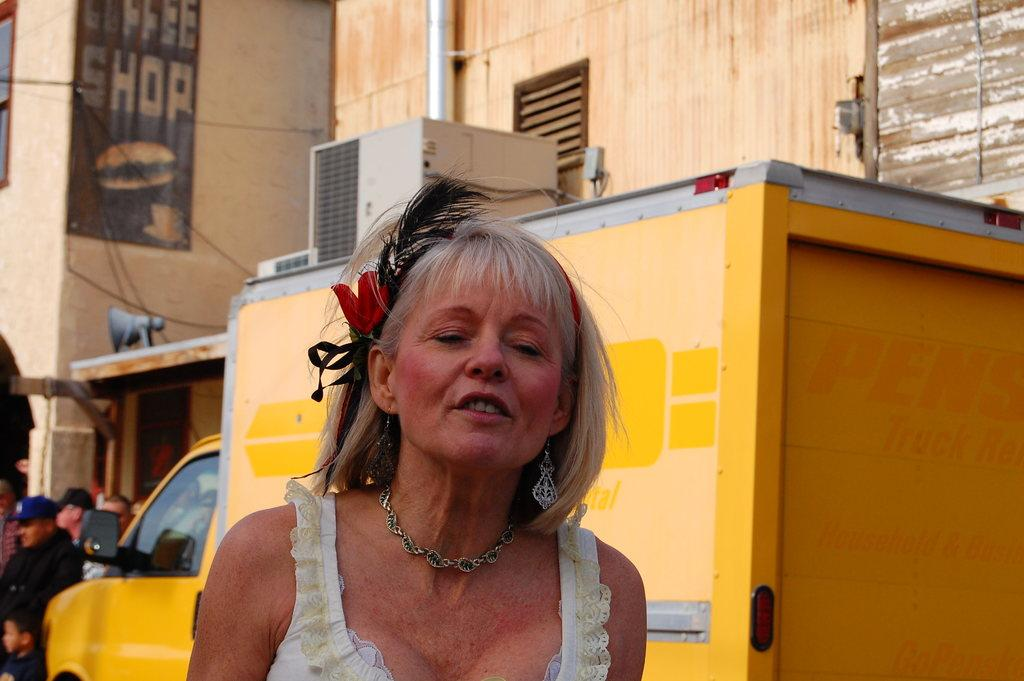<image>
Give a short and clear explanation of the subsequent image. A woman with her eyes closed stands in front of a sign for a coffee shop. 